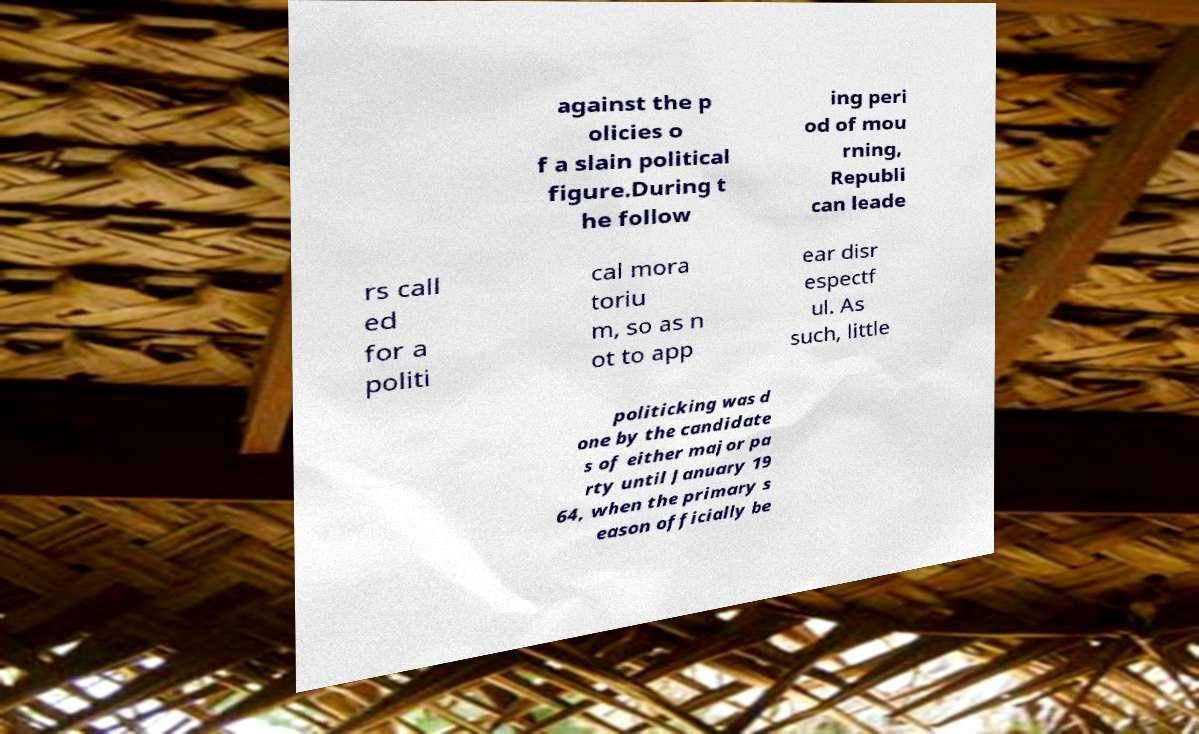Please read and relay the text visible in this image. What does it say? against the p olicies o f a slain political figure.During t he follow ing peri od of mou rning, Republi can leade rs call ed for a politi cal mora toriu m, so as n ot to app ear disr espectf ul. As such, little politicking was d one by the candidate s of either major pa rty until January 19 64, when the primary s eason officially be 